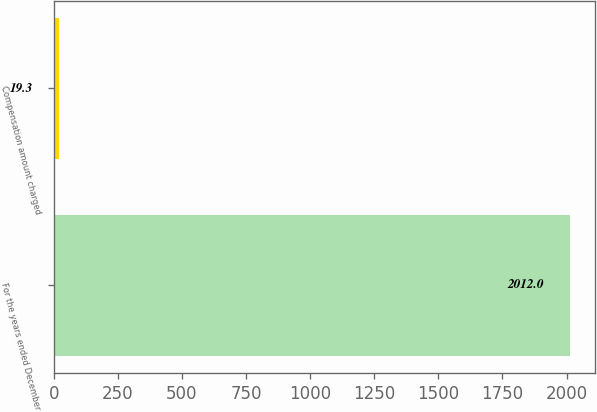Convert chart to OTSL. <chart><loc_0><loc_0><loc_500><loc_500><bar_chart><fcel>For the years ended December<fcel>Compensation amount charged<nl><fcel>2012<fcel>19.3<nl></chart> 